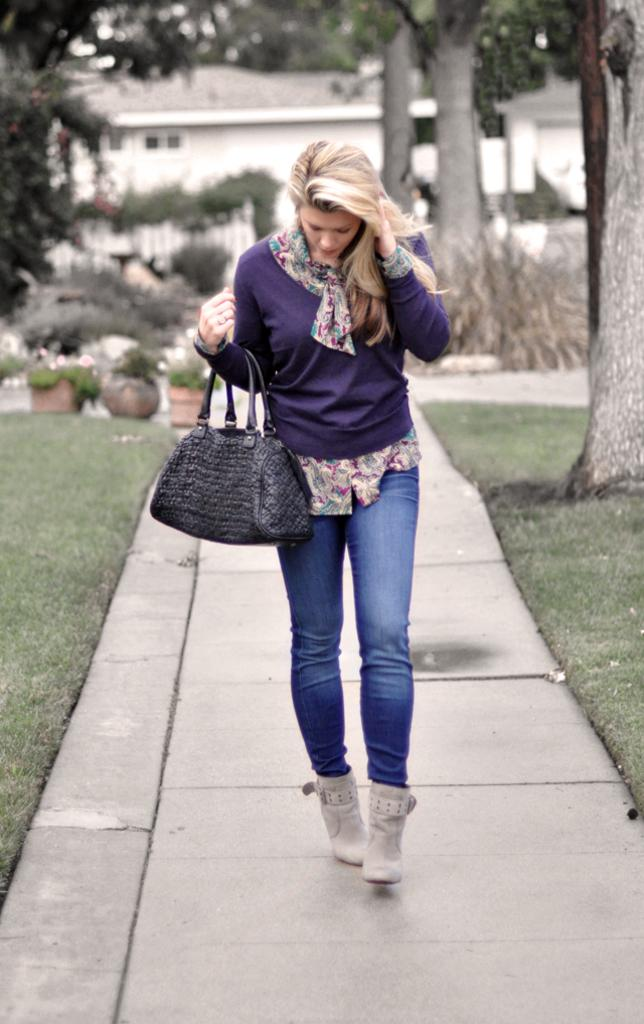Who is the main subject in the image? There is a woman in the image. What is the woman doing in the image? The woman is walking. What is the woman carrying in the image? The woman is carrying a handbag. What can be seen in the background of the image? There is a house, trees, and plants in the background of the image. What type of butter is being spread on the trees in the image? There is no butter present in the image, and the trees are not being spread with anything. 